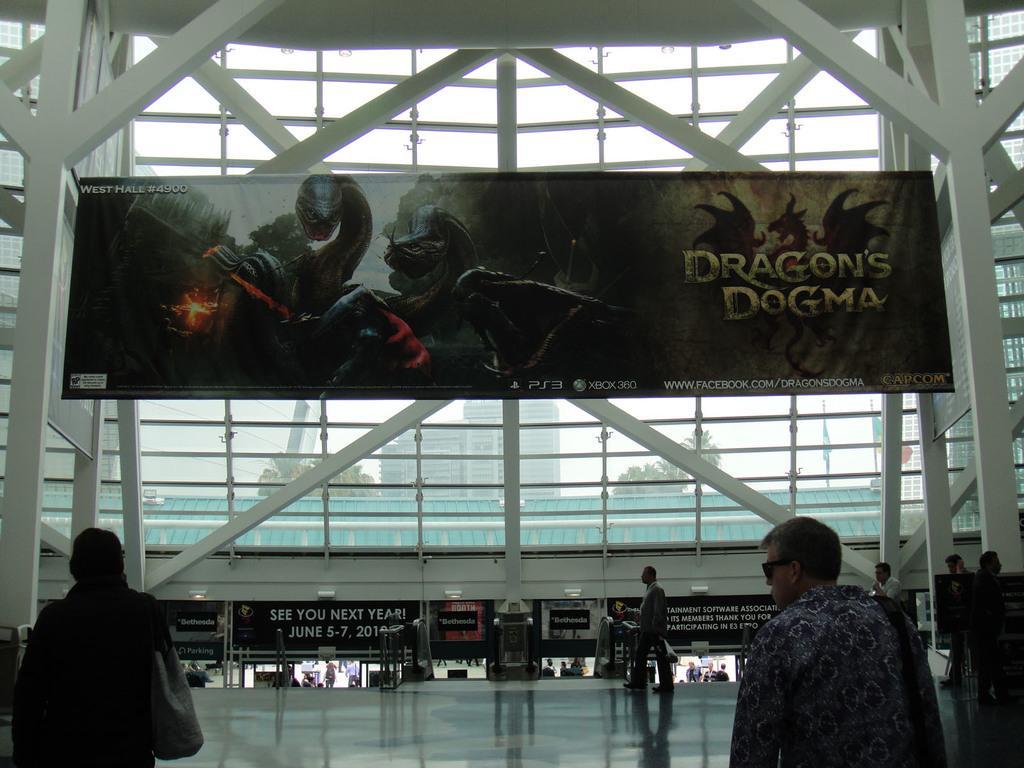Could you give a brief overview of what you see in this image? There are persons walking on the floor. Above them, there is a hoarding which is attached to the pillars of a building which is having glass windows. Through this window, we can see, there are trees, building and there is sky. 